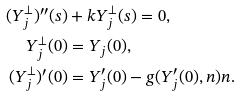<formula> <loc_0><loc_0><loc_500><loc_500>( Y _ { j } ^ { \bot } ) ^ { \prime \prime } ( s ) & + k Y _ { j } ^ { \bot } ( s ) = 0 , \\ Y _ { j } ^ { \bot } ( 0 ) & = Y _ { j } ( 0 ) , \\ ( Y _ { j } ^ { \bot } ) ^ { \prime } ( 0 ) & = Y _ { j } ^ { \prime } ( 0 ) - g ( Y _ { j } ^ { \prime } ( 0 ) , n ) n .</formula> 